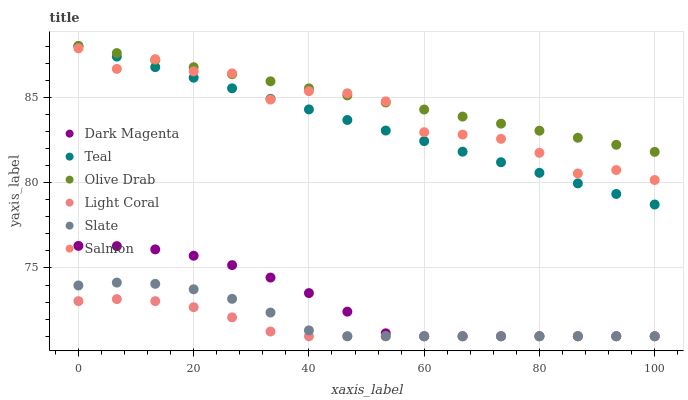Does Light Coral have the minimum area under the curve?
Answer yes or no. Yes. Does Olive Drab have the maximum area under the curve?
Answer yes or no. Yes. Does Slate have the minimum area under the curve?
Answer yes or no. No. Does Slate have the maximum area under the curve?
Answer yes or no. No. Is Teal the smoothest?
Answer yes or no. Yes. Is Salmon the roughest?
Answer yes or no. Yes. Is Slate the smoothest?
Answer yes or no. No. Is Slate the roughest?
Answer yes or no. No. Does Dark Magenta have the lowest value?
Answer yes or no. Yes. Does Salmon have the lowest value?
Answer yes or no. No. Does Olive Drab have the highest value?
Answer yes or no. Yes. Does Slate have the highest value?
Answer yes or no. No. Is Dark Magenta less than Salmon?
Answer yes or no. Yes. Is Olive Drab greater than Light Coral?
Answer yes or no. Yes. Does Teal intersect Olive Drab?
Answer yes or no. Yes. Is Teal less than Olive Drab?
Answer yes or no. No. Is Teal greater than Olive Drab?
Answer yes or no. No. Does Dark Magenta intersect Salmon?
Answer yes or no. No. 